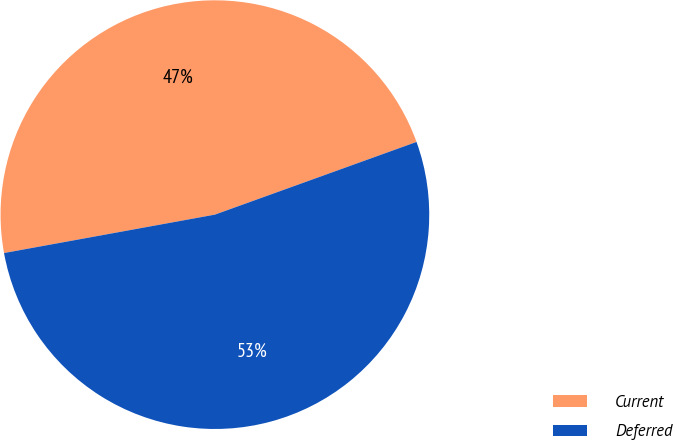Convert chart. <chart><loc_0><loc_0><loc_500><loc_500><pie_chart><fcel>Current<fcel>Deferred<nl><fcel>47.36%<fcel>52.64%<nl></chart> 